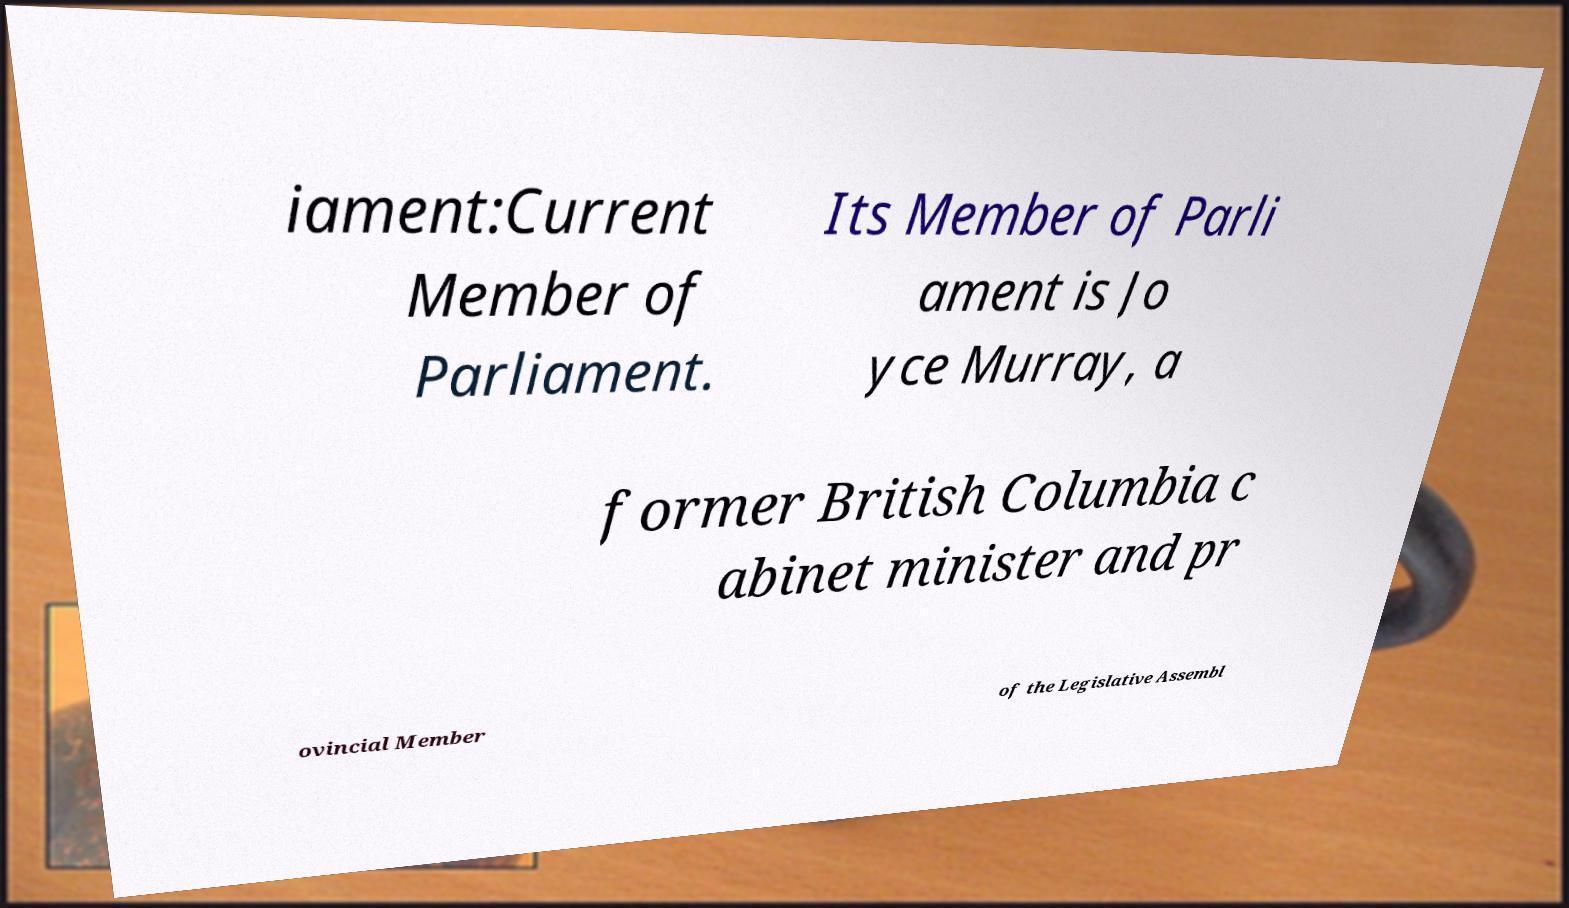I need the written content from this picture converted into text. Can you do that? iament:Current Member of Parliament. Its Member of Parli ament is Jo yce Murray, a former British Columbia c abinet minister and pr ovincial Member of the Legislative Assembl 